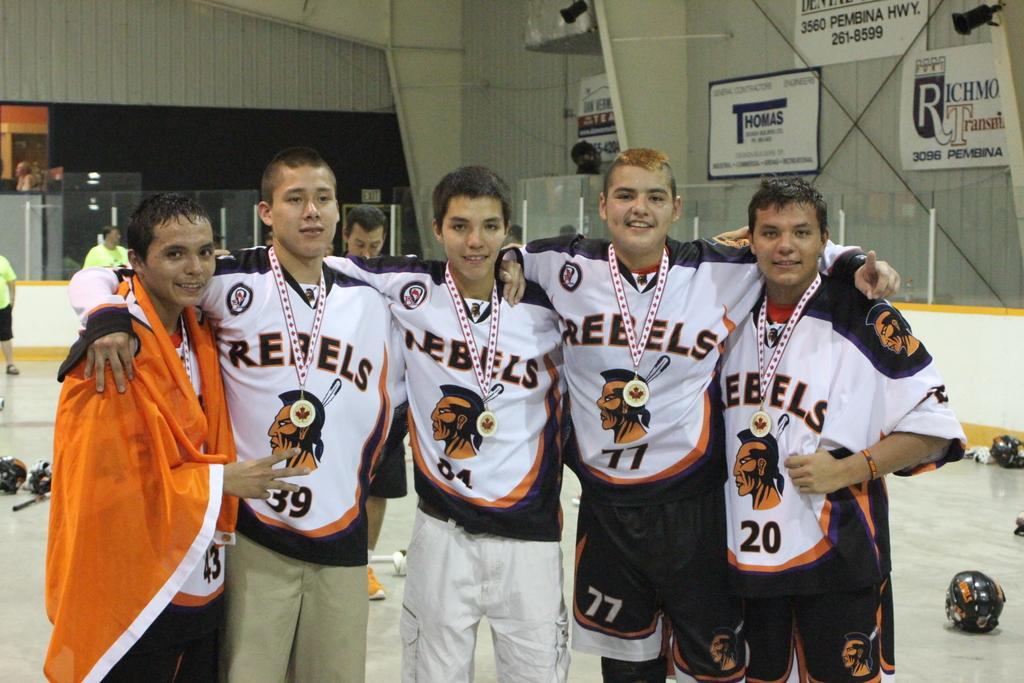<image>
Describe the image concisely. Five boys posing for on ice wearing jerseys that say Rebels. 